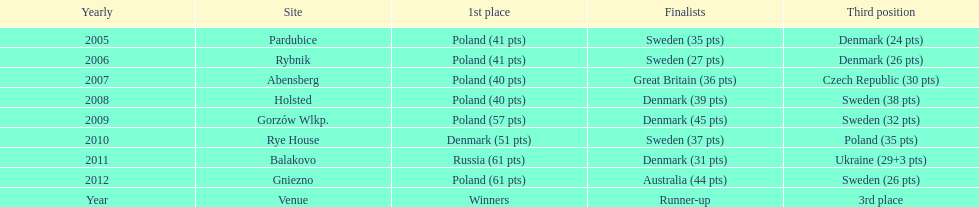From 2005-2012, in the team speedway junior world championship, how many more first place wins than all other teams put together? Poland. 